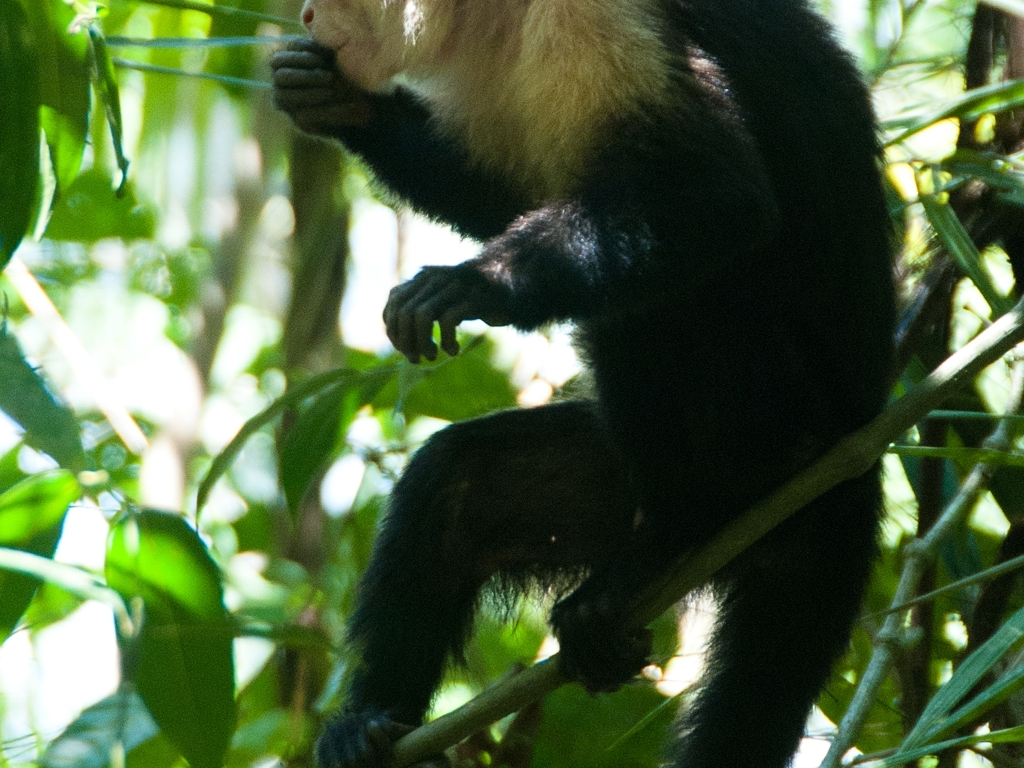What does the presence of this animal tell us about the health of the ecosystem it is in? Primarily, the presence of such primates can signify a relatively healthy ecosystem, as they often require extensive and diverse regions of forest to thrive. Their role as seed dispersers and their place in the food web is indicative of a balanced environment. Furthermore, the lush vegetation implies a rich biodiversity, which is crucial for sustaining various species, including this primate. 